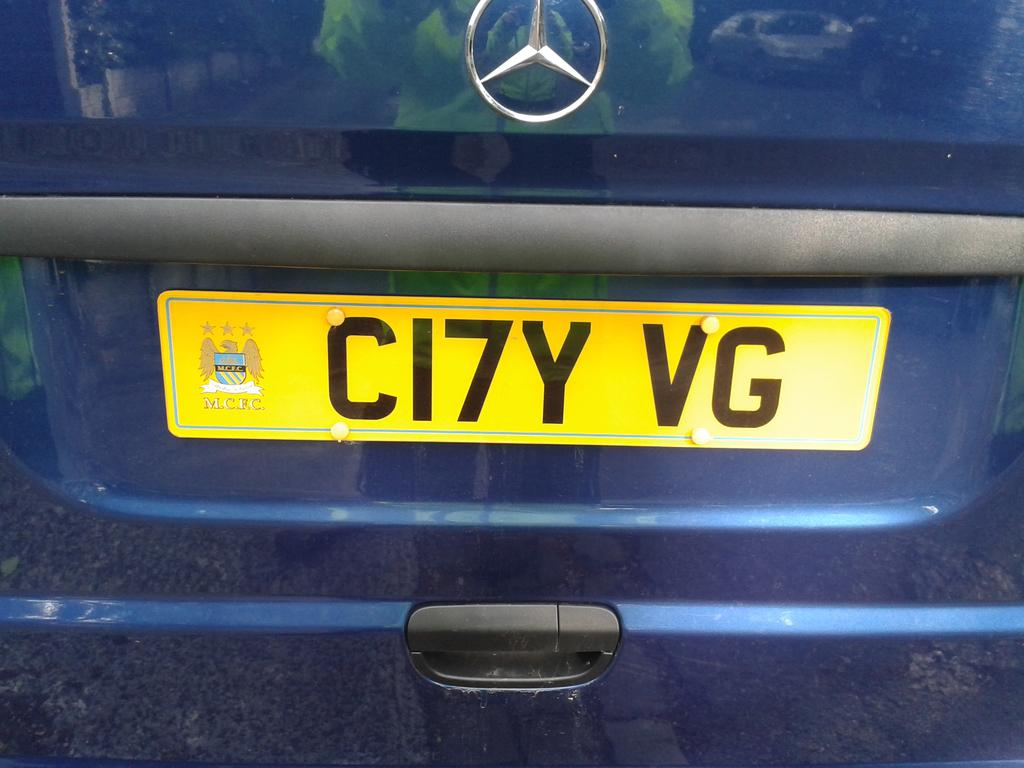<image>
Present a compact description of the photo's key features. A Mercedes van has a yellow licence plate that says CI7Y VG. 